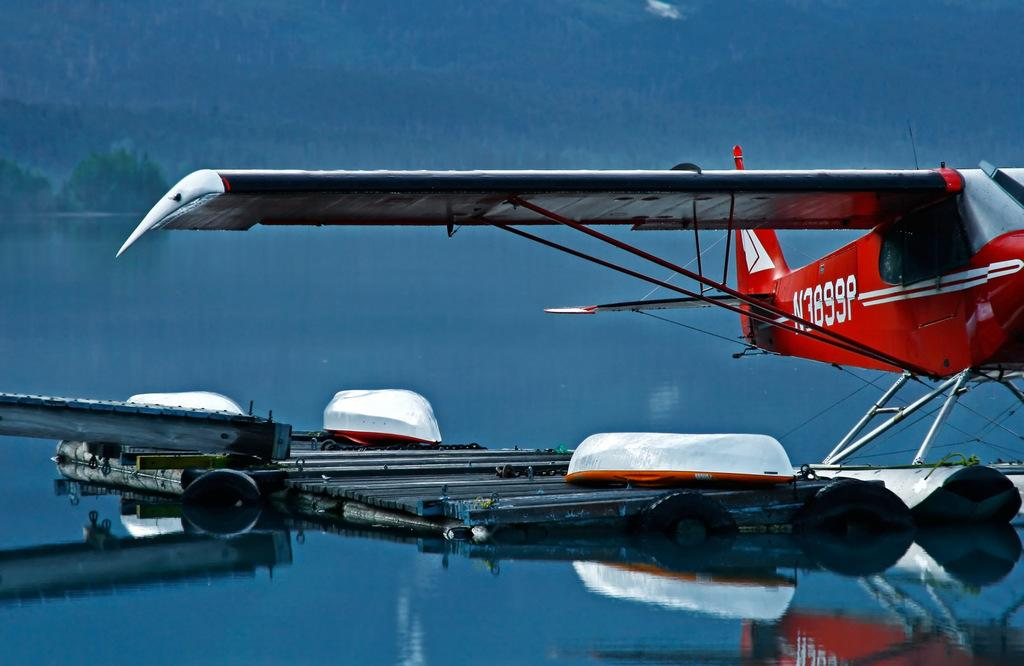What is the main subject in the image? There is a boat in the image. Where is the boat located? The boat is on the water. What other mode of transportation can be seen in the image? There is an aircraft in the image. What colors is the aircraft? The aircraft is in red and ash color. What can be seen in the background of the image? There are many trees in the background of the image. How many sisters are depicted in the image? There are no sisters present in the image; it features a boat, an aircraft, and trees in the background. 